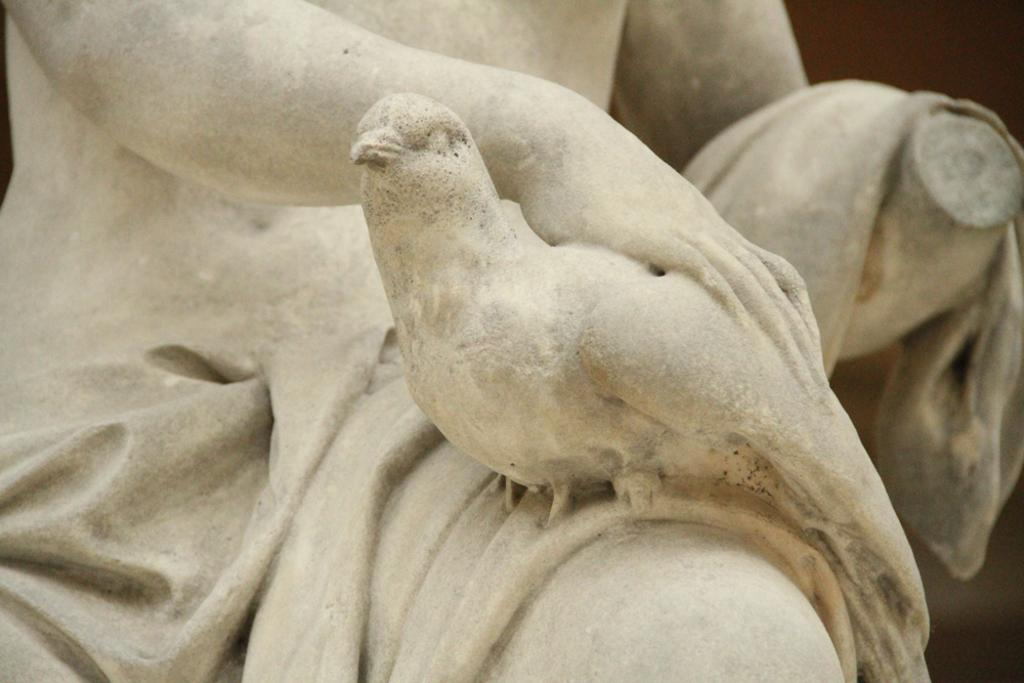What is the main subject in the image? There is a statue in the image. Can you describe the statue's appearance? The statue is in cream color. How much knowledge can be gained from the dime in the image? There is no dime present in the image, so no knowledge can be gained from it. 